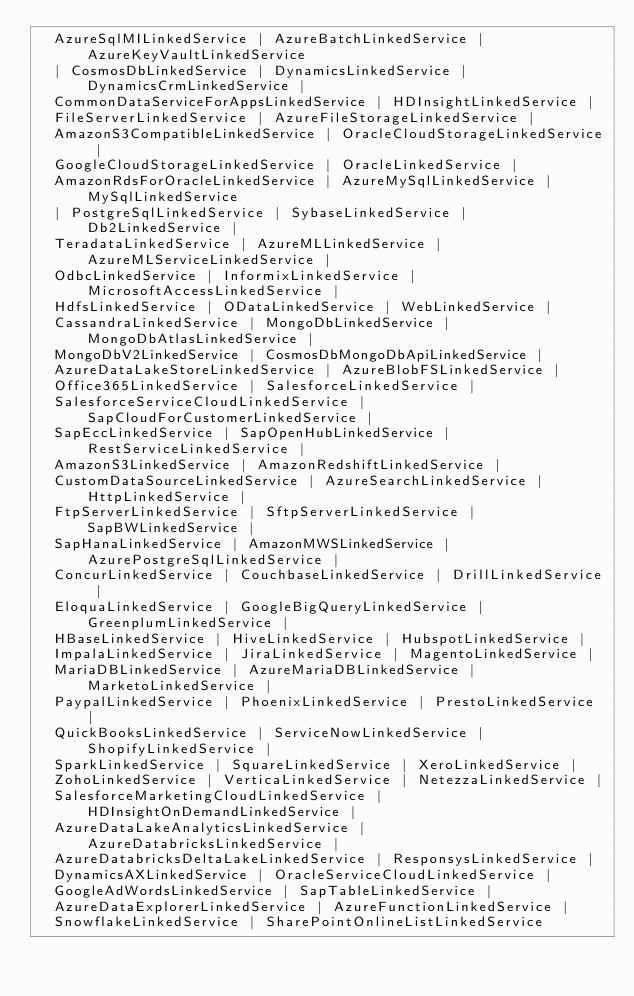<code> <loc_0><loc_0><loc_500><loc_500><_YAML_>  AzureSqlMILinkedService | AzureBatchLinkedService | AzureKeyVaultLinkedService
  | CosmosDbLinkedService | DynamicsLinkedService | DynamicsCrmLinkedService |
  CommonDataServiceForAppsLinkedService | HDInsightLinkedService |
  FileServerLinkedService | AzureFileStorageLinkedService |
  AmazonS3CompatibleLinkedService | OracleCloudStorageLinkedService |
  GoogleCloudStorageLinkedService | OracleLinkedService |
  AmazonRdsForOracleLinkedService | AzureMySqlLinkedService | MySqlLinkedService
  | PostgreSqlLinkedService | SybaseLinkedService | Db2LinkedService |
  TeradataLinkedService | AzureMLLinkedService | AzureMLServiceLinkedService |
  OdbcLinkedService | InformixLinkedService | MicrosoftAccessLinkedService |
  HdfsLinkedService | ODataLinkedService | WebLinkedService |
  CassandraLinkedService | MongoDbLinkedService | MongoDbAtlasLinkedService |
  MongoDbV2LinkedService | CosmosDbMongoDbApiLinkedService |
  AzureDataLakeStoreLinkedService | AzureBlobFSLinkedService |
  Office365LinkedService | SalesforceLinkedService |
  SalesforceServiceCloudLinkedService | SapCloudForCustomerLinkedService |
  SapEccLinkedService | SapOpenHubLinkedService | RestServiceLinkedService |
  AmazonS3LinkedService | AmazonRedshiftLinkedService |
  CustomDataSourceLinkedService | AzureSearchLinkedService | HttpLinkedService |
  FtpServerLinkedService | SftpServerLinkedService | SapBWLinkedService |
  SapHanaLinkedService | AmazonMWSLinkedService | AzurePostgreSqlLinkedService |
  ConcurLinkedService | CouchbaseLinkedService | DrillLinkedService |
  EloquaLinkedService | GoogleBigQueryLinkedService | GreenplumLinkedService |
  HBaseLinkedService | HiveLinkedService | HubspotLinkedService |
  ImpalaLinkedService | JiraLinkedService | MagentoLinkedService |
  MariaDBLinkedService | AzureMariaDBLinkedService | MarketoLinkedService |
  PaypalLinkedService | PhoenixLinkedService | PrestoLinkedService |
  QuickBooksLinkedService | ServiceNowLinkedService | ShopifyLinkedService |
  SparkLinkedService | SquareLinkedService | XeroLinkedService |
  ZohoLinkedService | VerticaLinkedService | NetezzaLinkedService |
  SalesforceMarketingCloudLinkedService | HDInsightOnDemandLinkedService |
  AzureDataLakeAnalyticsLinkedService | AzureDatabricksLinkedService |
  AzureDatabricksDeltaLakeLinkedService | ResponsysLinkedService |
  DynamicsAXLinkedService | OracleServiceCloudLinkedService |
  GoogleAdWordsLinkedService | SapTableLinkedService |
  AzureDataExplorerLinkedService | AzureFunctionLinkedService |
  SnowflakeLinkedService | SharePointOnlineListLinkedService
</code> 